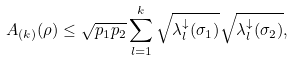Convert formula to latex. <formula><loc_0><loc_0><loc_500><loc_500>A _ { ( k ) } ( \rho ) \leq \sqrt { p _ { 1 } p _ { 2 } } \sum _ { l = 1 } ^ { k } \sqrt { \lambda _ { l } ^ { \downarrow } ( \sigma _ { 1 } ) } \sqrt { \lambda _ { l } ^ { \downarrow } ( \sigma _ { 2 } ) } ,</formula> 